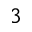<formula> <loc_0><loc_0><loc_500><loc_500>^ { 3 }</formula> 